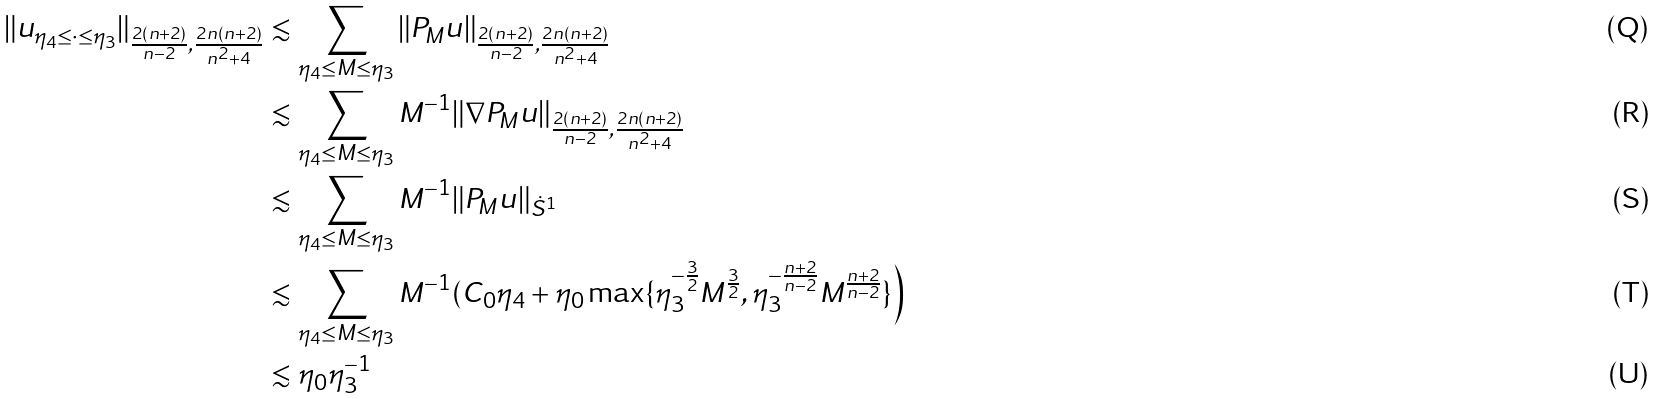Convert formula to latex. <formula><loc_0><loc_0><loc_500><loc_500>\| u _ { \eta _ { 4 } \leq \cdot \leq \eta _ { 3 } } \| _ { \frac { 2 ( n + 2 ) } { n - 2 } , \frac { 2 n ( n + 2 ) } { n ^ { 2 } + 4 } } & \lesssim \sum _ { \eta _ { 4 } \leq M \leq \eta _ { 3 } } \| P _ { M } u \| _ { \frac { 2 ( n + 2 ) } { n - 2 } , \frac { 2 n ( n + 2 ) } { n ^ { 2 } + 4 } } \\ & \lesssim \sum _ { \eta _ { 4 } \leq M \leq \eta _ { 3 } } M ^ { - 1 } \| \nabla P _ { M } u \| _ { \frac { 2 ( n + 2 ) } { n - 2 } , \frac { 2 n ( n + 2 ) } { n ^ { 2 } + 4 } } \\ & \lesssim \sum _ { \eta _ { 4 } \leq M \leq \eta _ { 3 } } M ^ { - 1 } \| P _ { M } u \| _ { \dot { S } ^ { 1 } } \\ & \lesssim \sum _ { \eta _ { 4 } \leq M \leq \eta _ { 3 } } M ^ { - 1 } ( C _ { 0 } \eta _ { 4 } + \eta _ { 0 } \max \{ \eta _ { 3 } ^ { - \frac { 3 } { 2 } } M ^ { \frac { 3 } { 2 } } , \eta _ { 3 } ^ { - \frac { n + 2 } { n - 2 } } M ^ { \frac { n + 2 } { n - 2 } } \} \Big ) \\ & \lesssim \eta _ { 0 } \eta _ { 3 } ^ { - 1 }</formula> 